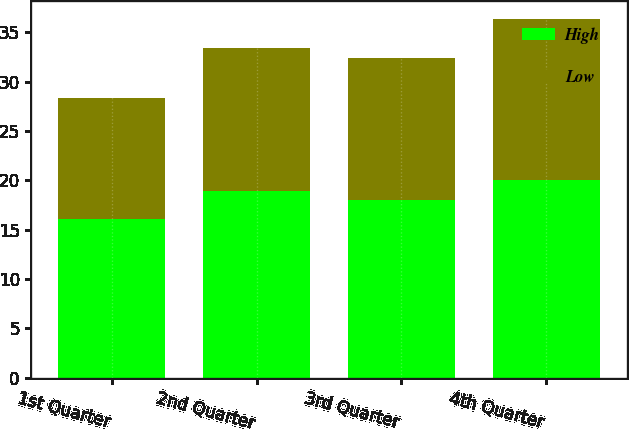Convert chart to OTSL. <chart><loc_0><loc_0><loc_500><loc_500><stacked_bar_chart><ecel><fcel>1st Quarter<fcel>2nd Quarter<fcel>3rd Quarter<fcel>4th Quarter<nl><fcel>High<fcel>16.09<fcel>18.92<fcel>18.02<fcel>20.05<nl><fcel>Low<fcel>12.24<fcel>14.47<fcel>14.4<fcel>16.32<nl></chart> 